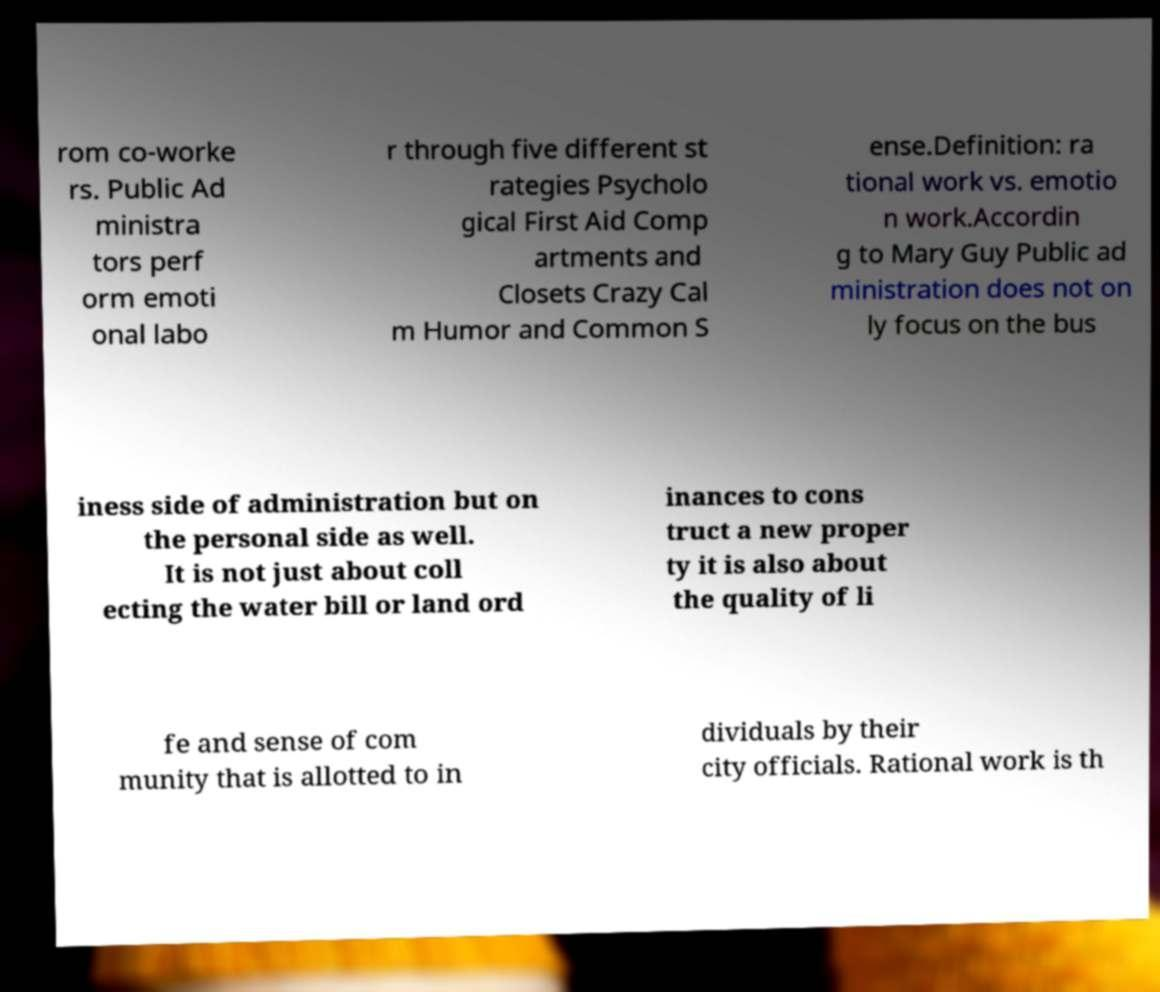I need the written content from this picture converted into text. Can you do that? rom co-worke rs. Public Ad ministra tors perf orm emoti onal labo r through five different st rategies Psycholo gical First Aid Comp artments and Closets Crazy Cal m Humor and Common S ense.Definition: ra tional work vs. emotio n work.Accordin g to Mary Guy Public ad ministration does not on ly focus on the bus iness side of administration but on the personal side as well. It is not just about coll ecting the water bill or land ord inances to cons truct a new proper ty it is also about the quality of li fe and sense of com munity that is allotted to in dividuals by their city officials. Rational work is th 